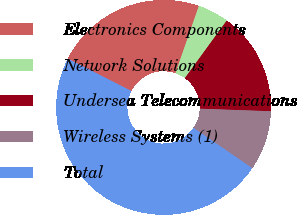Convert chart. <chart><loc_0><loc_0><loc_500><loc_500><pie_chart><fcel>Electronics Components<fcel>Network Solutions<fcel>Undersea Telecommunications<fcel>Wireless Systems (1)<fcel>Total<nl><fcel>22.84%<fcel>4.68%<fcel>15.56%<fcel>9.0%<fcel>47.92%<nl></chart> 